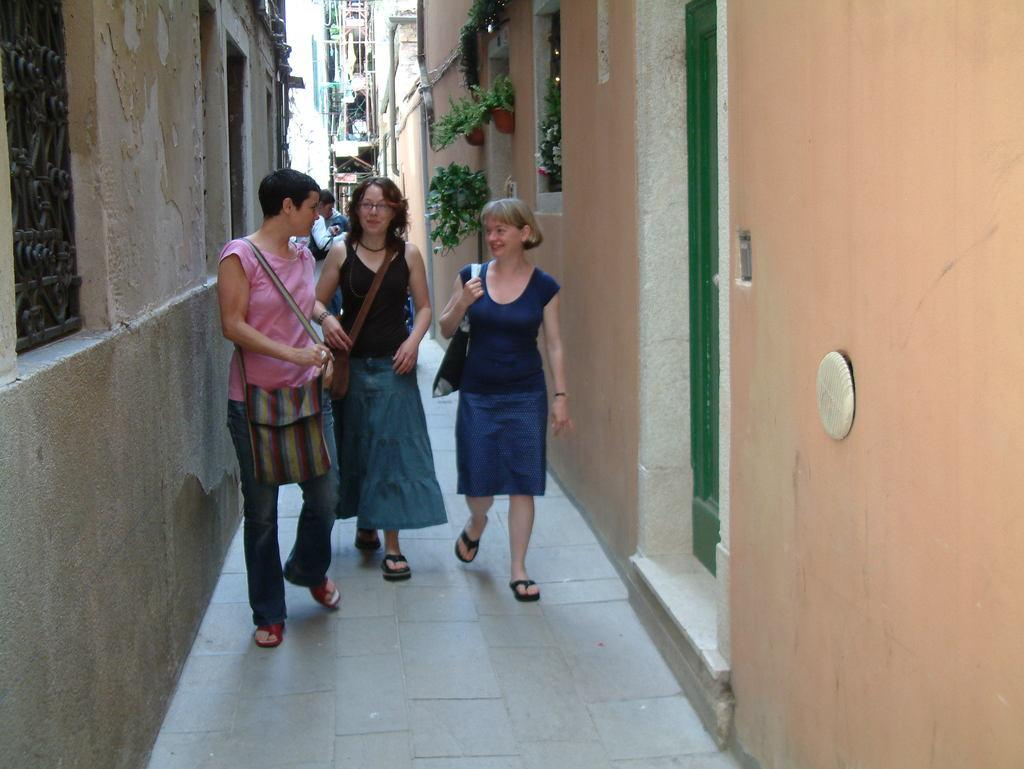Who or what can be seen in the image? There are people in the image. What type of structures are present in the image? There are buildings in the image. What type of vegetation is on the right side of the image? There are house plants on the right side of the image. What architectural feature is on the left side of the image? There is a window on the left side of the image. What is a possible entrance or exit in the image? There is a door visible in the image. What type of bean is being served on a tray in the image? There is no bean or tray present in the image. 